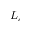Convert formula to latex. <formula><loc_0><loc_0><loc_500><loc_500>L _ { c }</formula> 